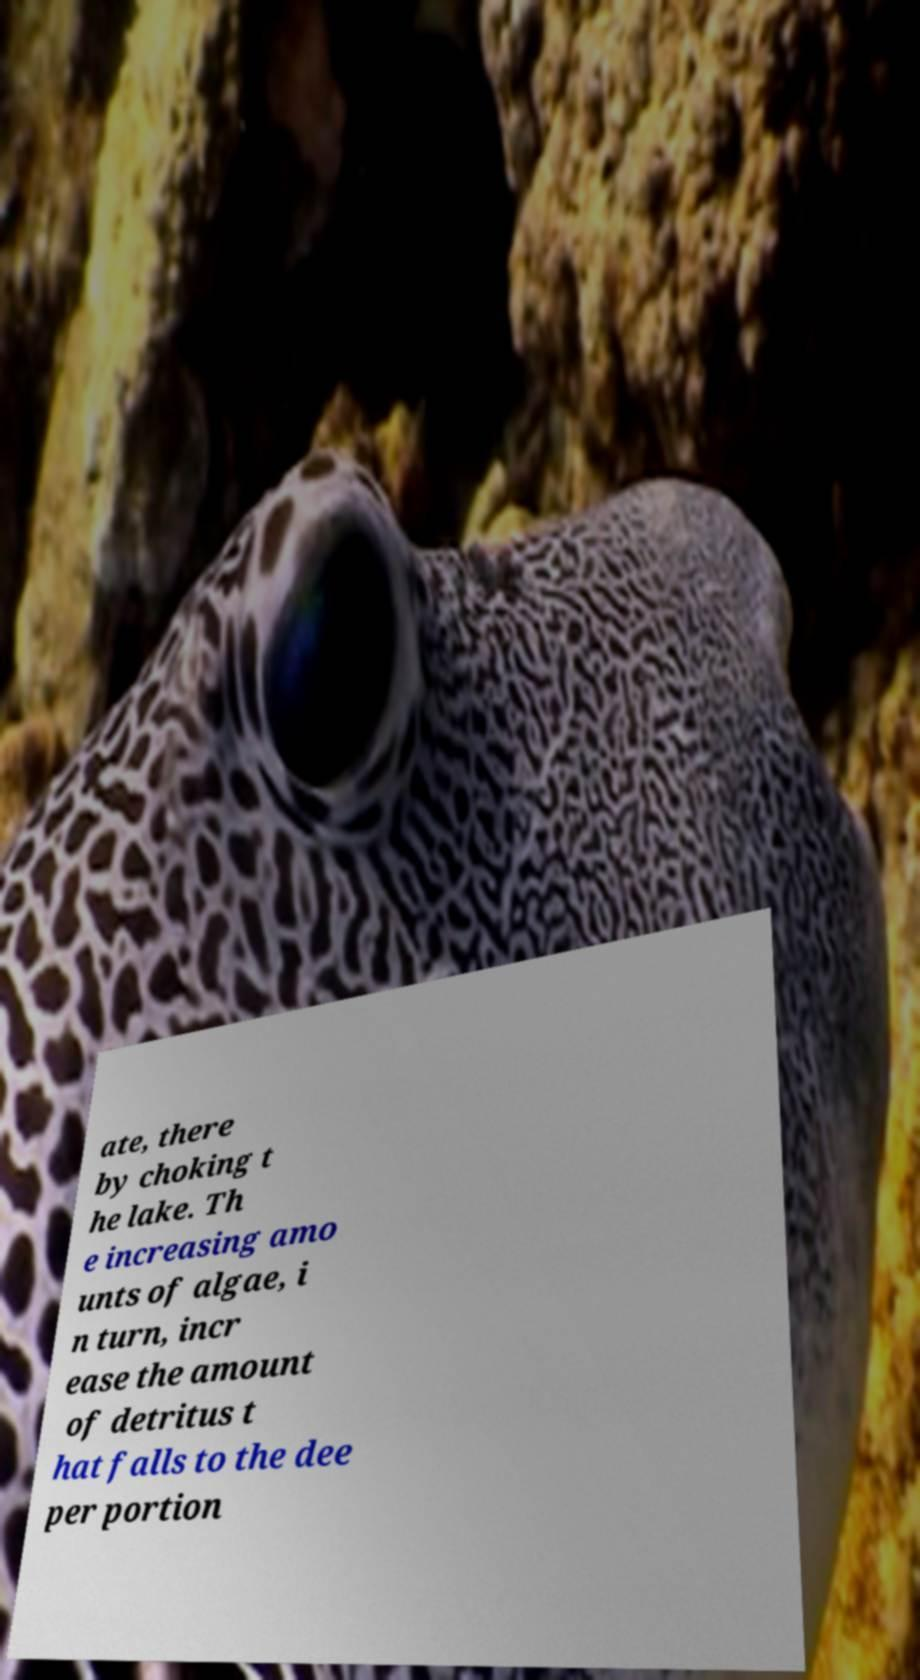Please identify and transcribe the text found in this image. ate, there by choking t he lake. Th e increasing amo unts of algae, i n turn, incr ease the amount of detritus t hat falls to the dee per portion 